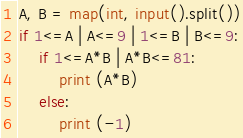Convert code to text. <code><loc_0><loc_0><loc_500><loc_500><_Python_>A, B = map(int, input().split())
if 1<=A | A<=9 | 1<=B | B<=9:
    if 1<=A*B | A*B<=81:
        print (A*B)
    else:
        print (-1)

</code> 